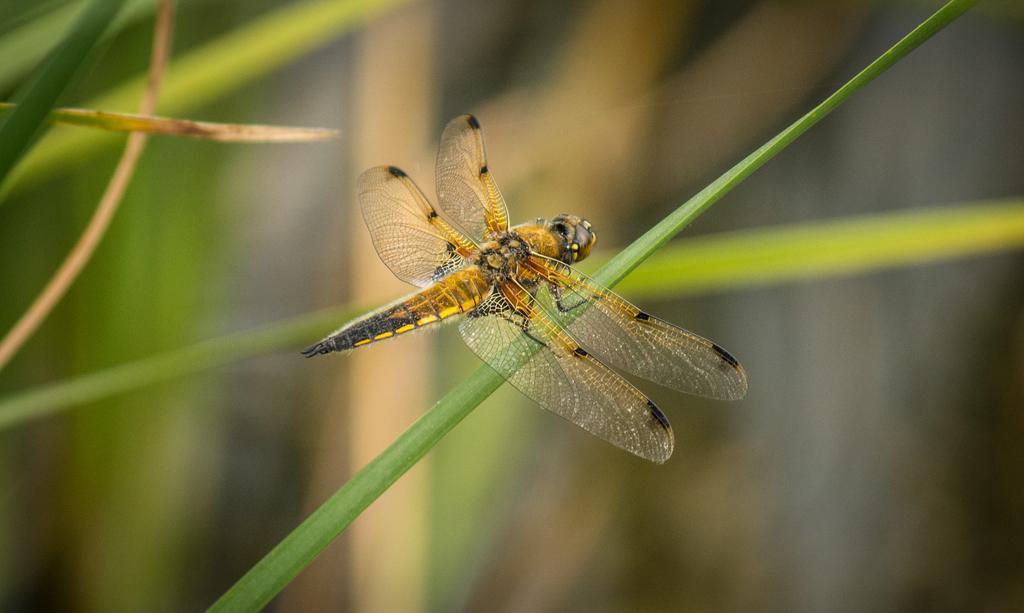In one or two sentences, can you explain what this image depicts? In the center of the image there is a fly on the plant. 